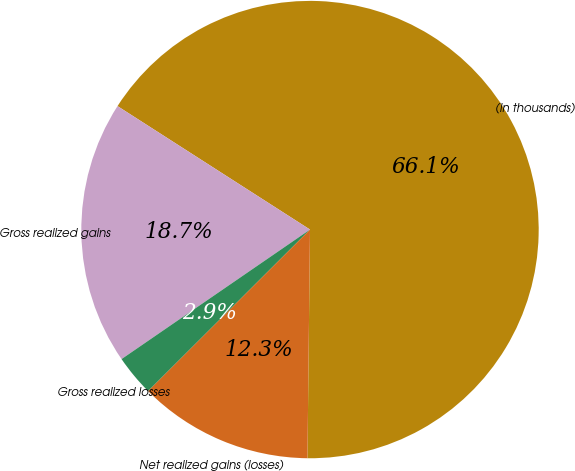Convert chart to OTSL. <chart><loc_0><loc_0><loc_500><loc_500><pie_chart><fcel>(In thousands)<fcel>Gross realized gains<fcel>Gross realized losses<fcel>Net realized gains (losses)<nl><fcel>66.1%<fcel>18.66%<fcel>2.9%<fcel>12.34%<nl></chart> 